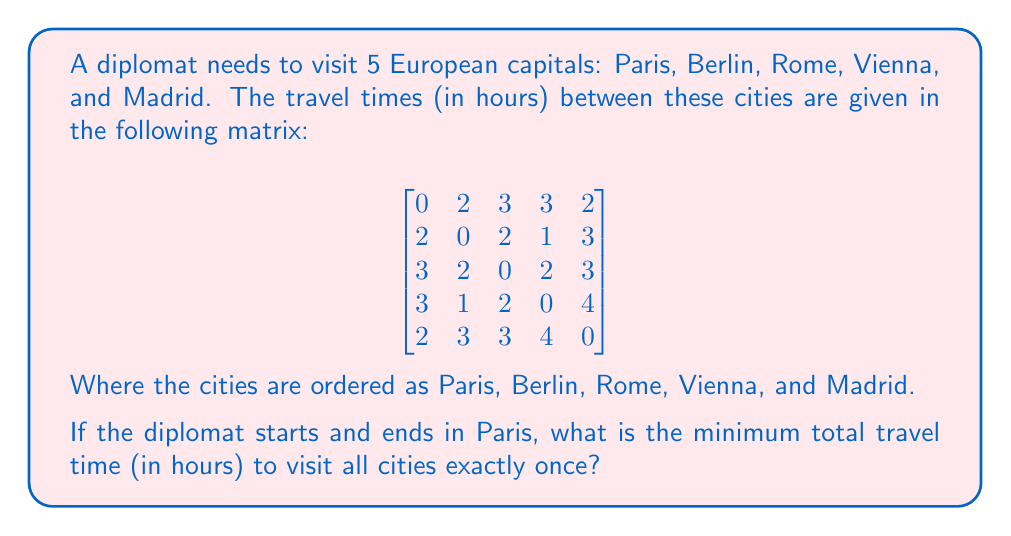Could you help me with this problem? This problem is an instance of the Traveling Salesman Problem (TSP), which is NP-hard. For a small number of cities like this, we can solve it using a brute-force approach.

1) First, we need to list all possible routes starting and ending in Paris (city 1):
   1-2-3-4-5-1, 1-2-3-5-4-1, 1-2-4-3-5-1, 1-2-4-5-3-1, 1-2-5-3-4-1, 1-2-5-4-3-1,
   1-3-2-4-5-1, 1-3-2-5-4-1, 1-3-4-2-5-1, 1-3-4-5-2-1, 1-3-5-2-4-1, 1-3-5-4-2-1,
   1-4-2-3-5-1, 1-4-2-5-3-1, 1-4-3-2-5-1, 1-4-3-5-2-1, 1-4-5-2-3-1, 1-4-5-3-2-1,
   1-5-2-3-4-1, 1-5-2-4-3-1, 1-5-3-2-4-1, 1-5-3-4-2-1, 1-5-4-2-3-1, 1-5-4-3-2-1

2) Now, we calculate the total travel time for each route. For example, for 1-2-3-4-5-1:
   Paris to Berlin: 2
   Berlin to Rome: 2
   Rome to Vienna: 2
   Vienna to Madrid: 4
   Madrid to Paris: 2
   Total: 2 + 2 + 2 + 4 + 2 = 12 hours

3) We repeat this process for all routes and keep track of the minimum.

4) After calculating all routes, we find that the minimum travel time is 10 hours.

5) This minimum is achieved by the route 1-2-4-3-5-1, which corresponds to:
   Paris -> Berlin -> Vienna -> Rome -> Madrid -> Paris
Answer: The minimum total travel time is 10 hours, achieved by the route Paris -> Berlin -> Vienna -> Rome -> Madrid -> Paris. 